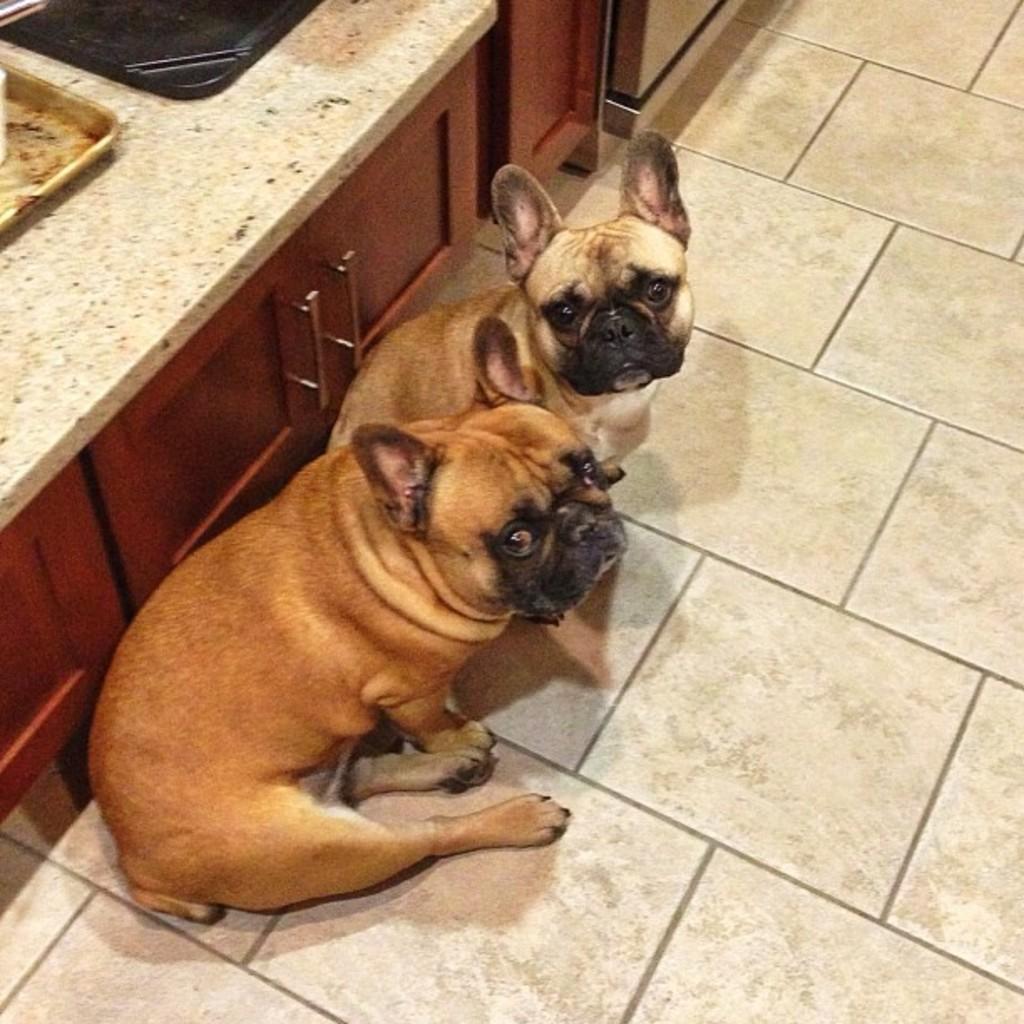How would you summarize this image in a sentence or two? In this image there are two dogs on the floor, and at the background there are cupboards, trays on the cabinet. 